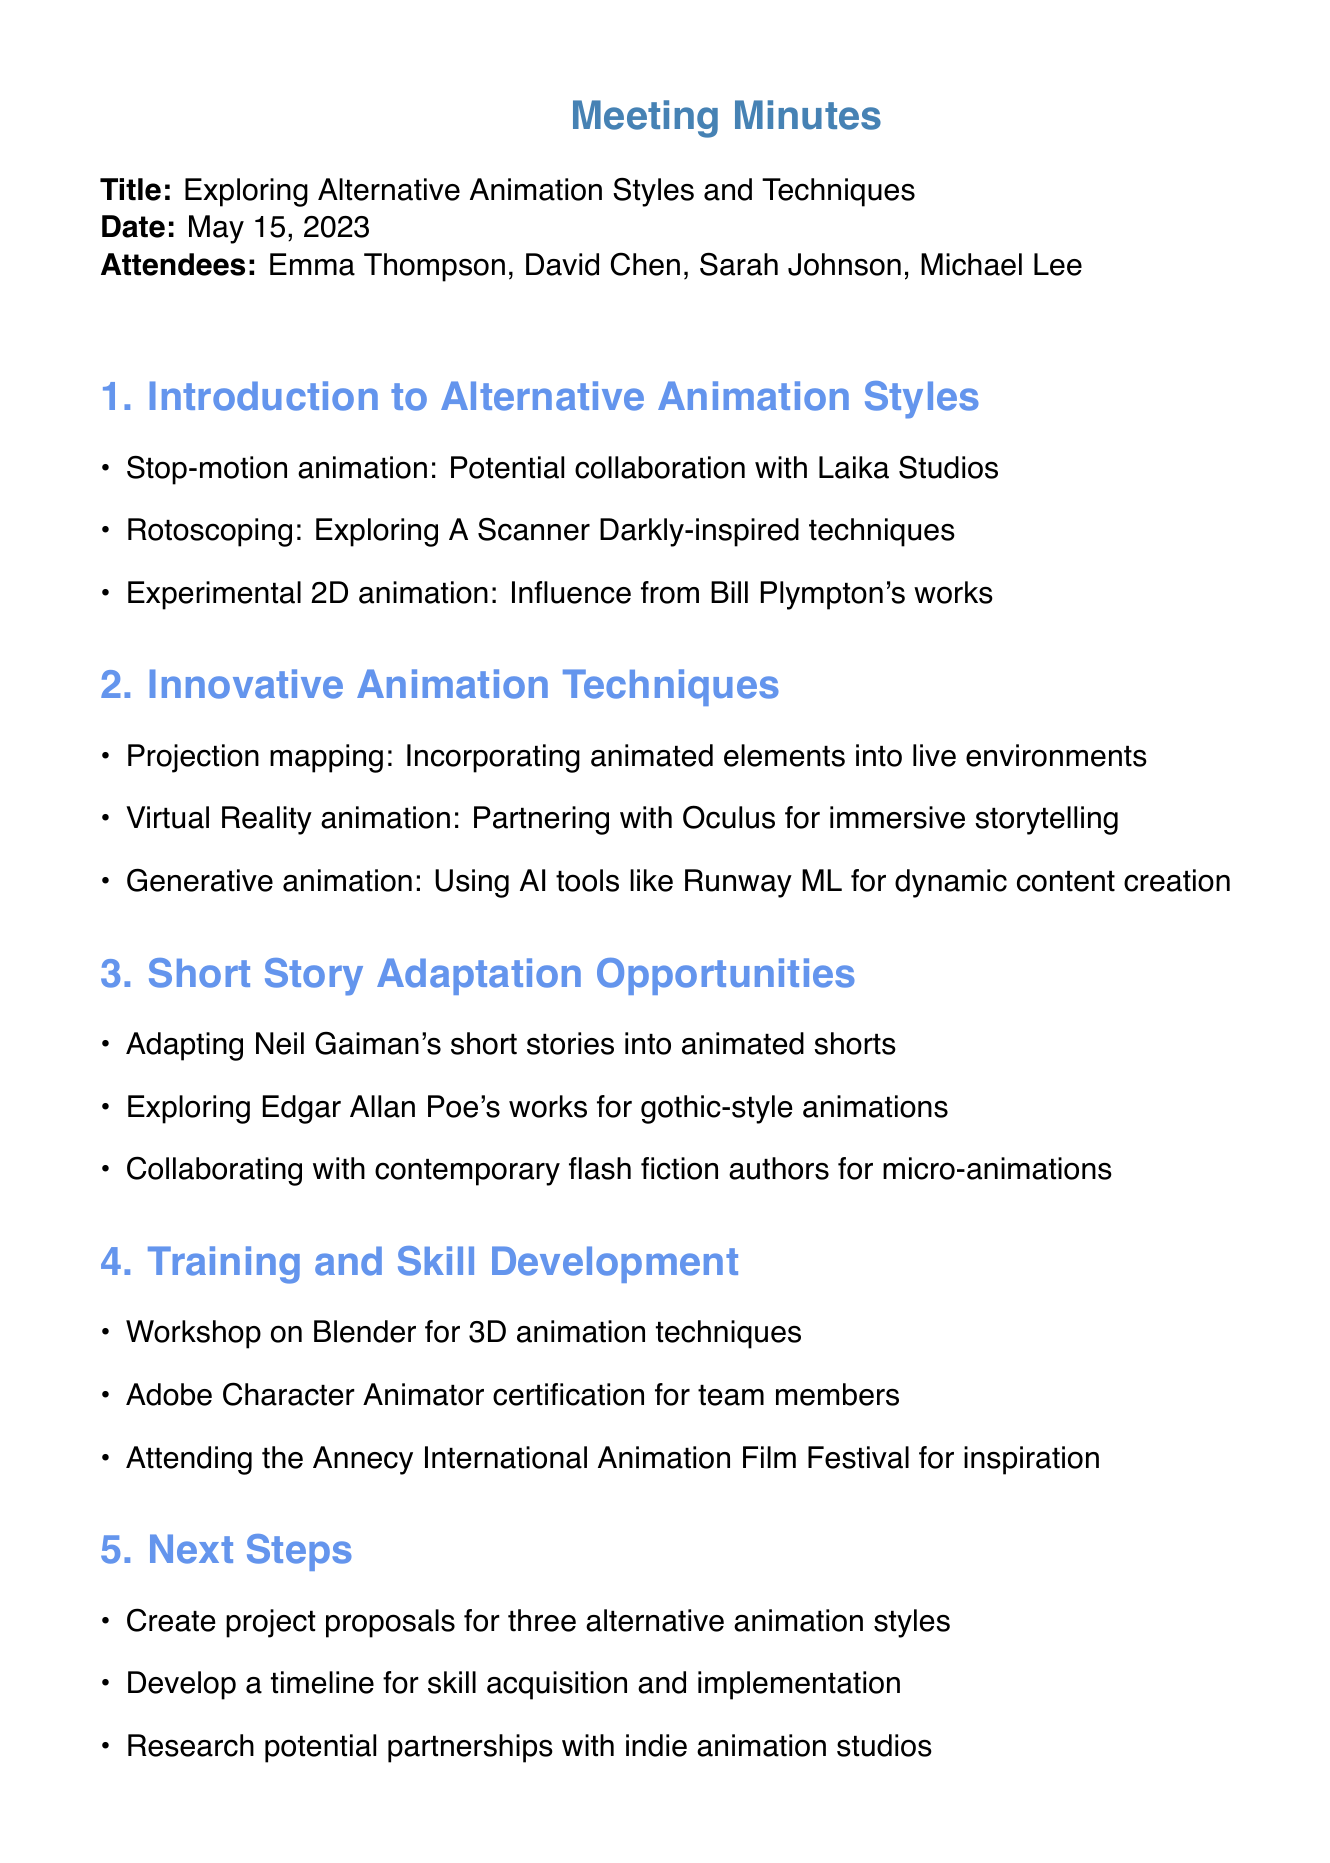What is the meeting title? The meeting title is stated at the beginning of the document under the "Title" section.
Answer: Exploring Alternative Animation Styles and Techniques Who was the Creative Director? The Creative Director's name is listed in the "Attendees" section of the document.
Answer: David Chen When did the meeting take place? The date of the meeting is mentioned right after the title in the document.
Answer: May 15, 2023 What animation style involves potential collaboration with Laika Studios? This information can be found in the "Introduction to Alternative Animation Styles" section where different animation styles are mentioned.
Answer: Stop-motion animation Which animation technique involves using AI tools like Runway ML? This is specified in the "Innovative Animation Techniques" section of the document.
Answer: Generative animation Name a famous author whose works are considered for adaptation into animated shorts. This author is mentioned in the "Short Story Adaptation Opportunities" section, focusing on adaptations.
Answer: Neil Gaiman What certification is suggested for team members? This information is found in the "Training and Skill Development" section where various training opportunities are listed.
Answer: Adobe Character Animator certification What is one of the next steps outlined in the meeting? The next steps are summarized in the last section of the document, detailing actions to be taken post-meeting.
Answer: Create project proposals for three alternative animation styles 